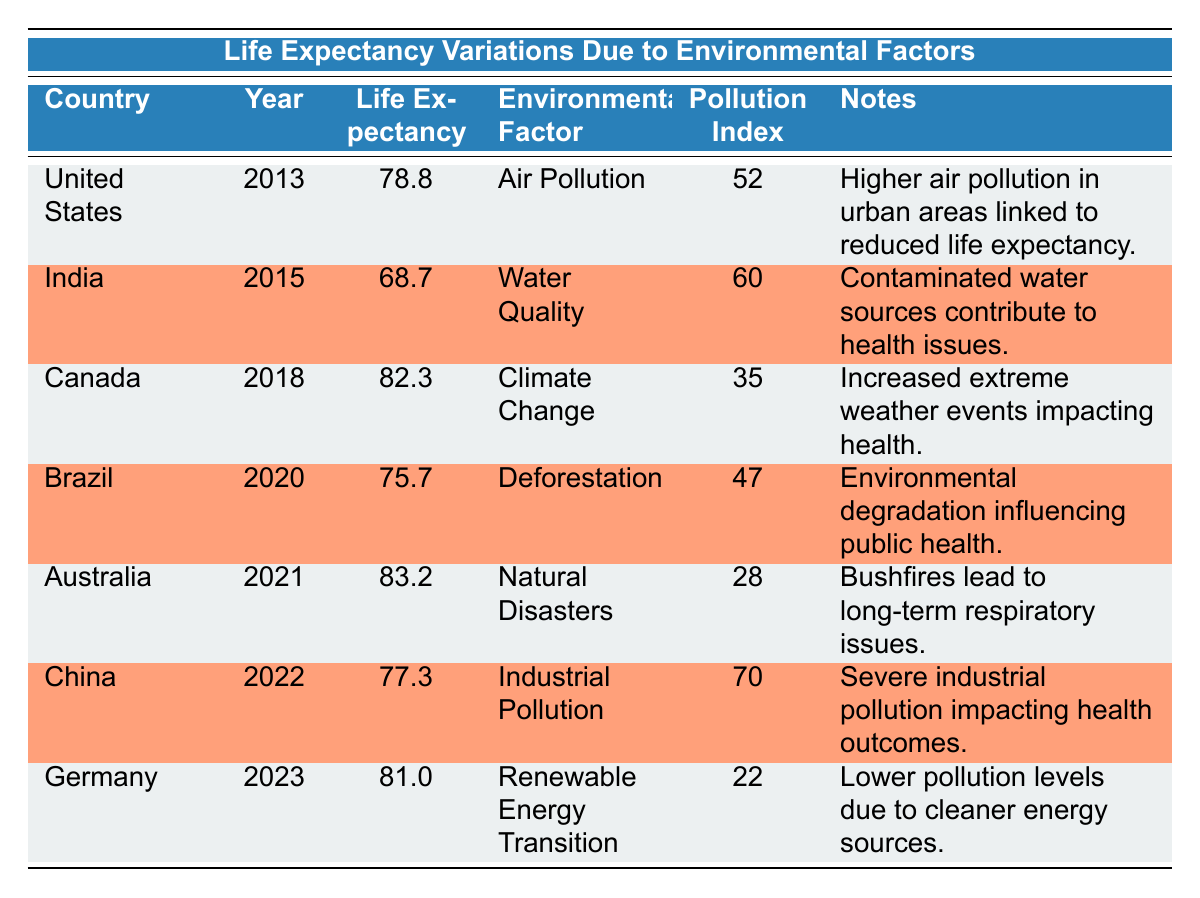What is the life expectancy of Australia in 2021? The table shows that Australia's life expectancy in 2021 is listed directly. Therefore, the life expectancy for Australia is 83.2 years in that year.
Answer: 83.2 Which country had the lowest life expectancy in the table? By reviewing the life expectancy figures, India had the lowest life expectancy at 68.7 years in 2015.
Answer: India What is the average life expectancy of the countries listed in the table? To calculate the average life expectancy, sum the life expectancies: (78.8 + 68.7 + 82.3 + 75.7 + 83.2 + 77.3 + 81.0) = 467.0. There are 7 data points, so the average is 467.0 / 7 = 66.71.
Answer: 66.71 Did Germany experience a decrease in life expectancy from 2022 to 2023? In 2022, China's life expectancy was 77.3, while Germany's in 2023 is 81.0. Since this is an increase, the statement is false.
Answer: No How do life expectancy and pollution index relate for the United States? The life expectancy for the United States in 2013 is 78.8 years, with a pollution index of 52. Higher pollution is linked to lower life expectancy, but to determine the relationship one would need to look at other data points; hence it seems this remains a concern in urban areas.
Answer: They are negatively correlated 